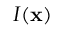<formula> <loc_0><loc_0><loc_500><loc_500>I ( x )</formula> 